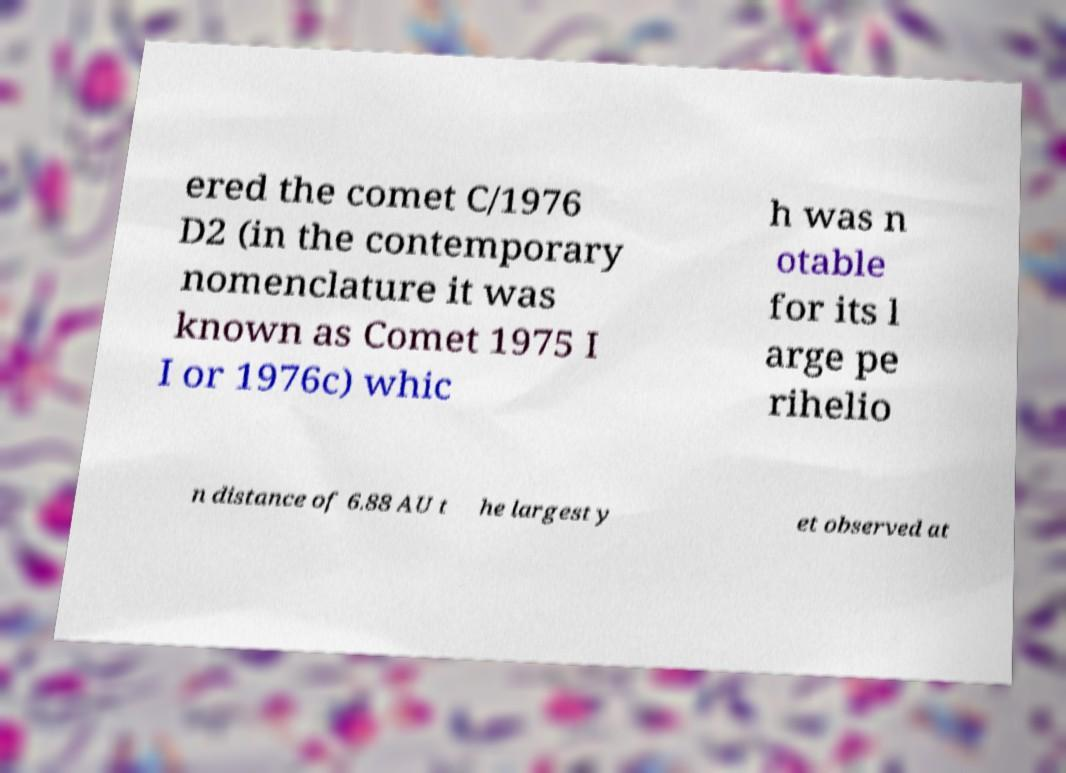What messages or text are displayed in this image? I need them in a readable, typed format. ered the comet C/1976 D2 (in the contemporary nomenclature it was known as Comet 1975 I I or 1976c) whic h was n otable for its l arge pe rihelio n distance of 6.88 AU t he largest y et observed at 